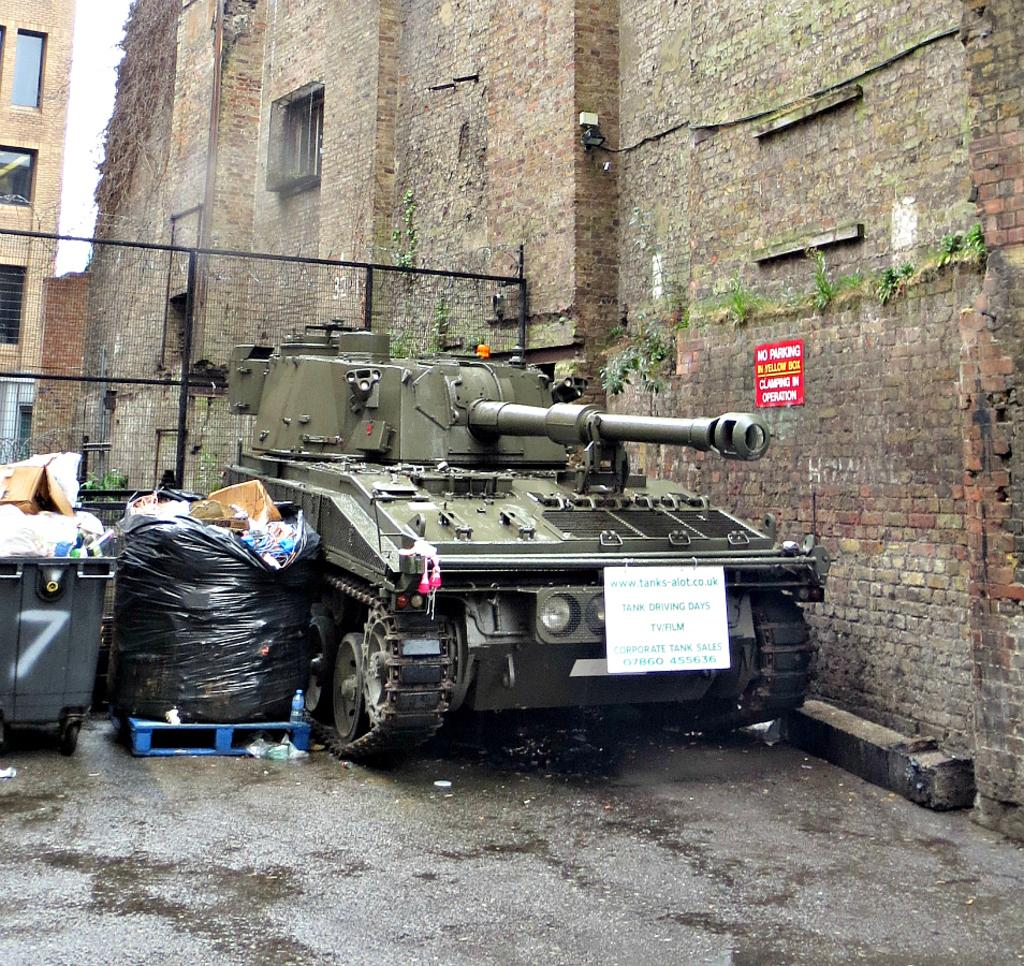What type of vehicle is present in the image? There is a military tank in the image. What objects can be seen near the ground in the image? There are dustbins in the image. What is the surface on which the objects are placed in the image? The ground is visible in the image. What can be seen on the wall in the image? There are objects on the wall in the image. What type of barrier is present in the image? There is a fence in the image. What type of structure is visible in the image? There is a building in the image. What part of the natural environment is visible in the image? The sky is visible in the image. Can you see any quince trees in the image? There are no quince trees present in the image. How many hands are visible holding the fence in the image? There are no hands visible holding the fence in the image. 